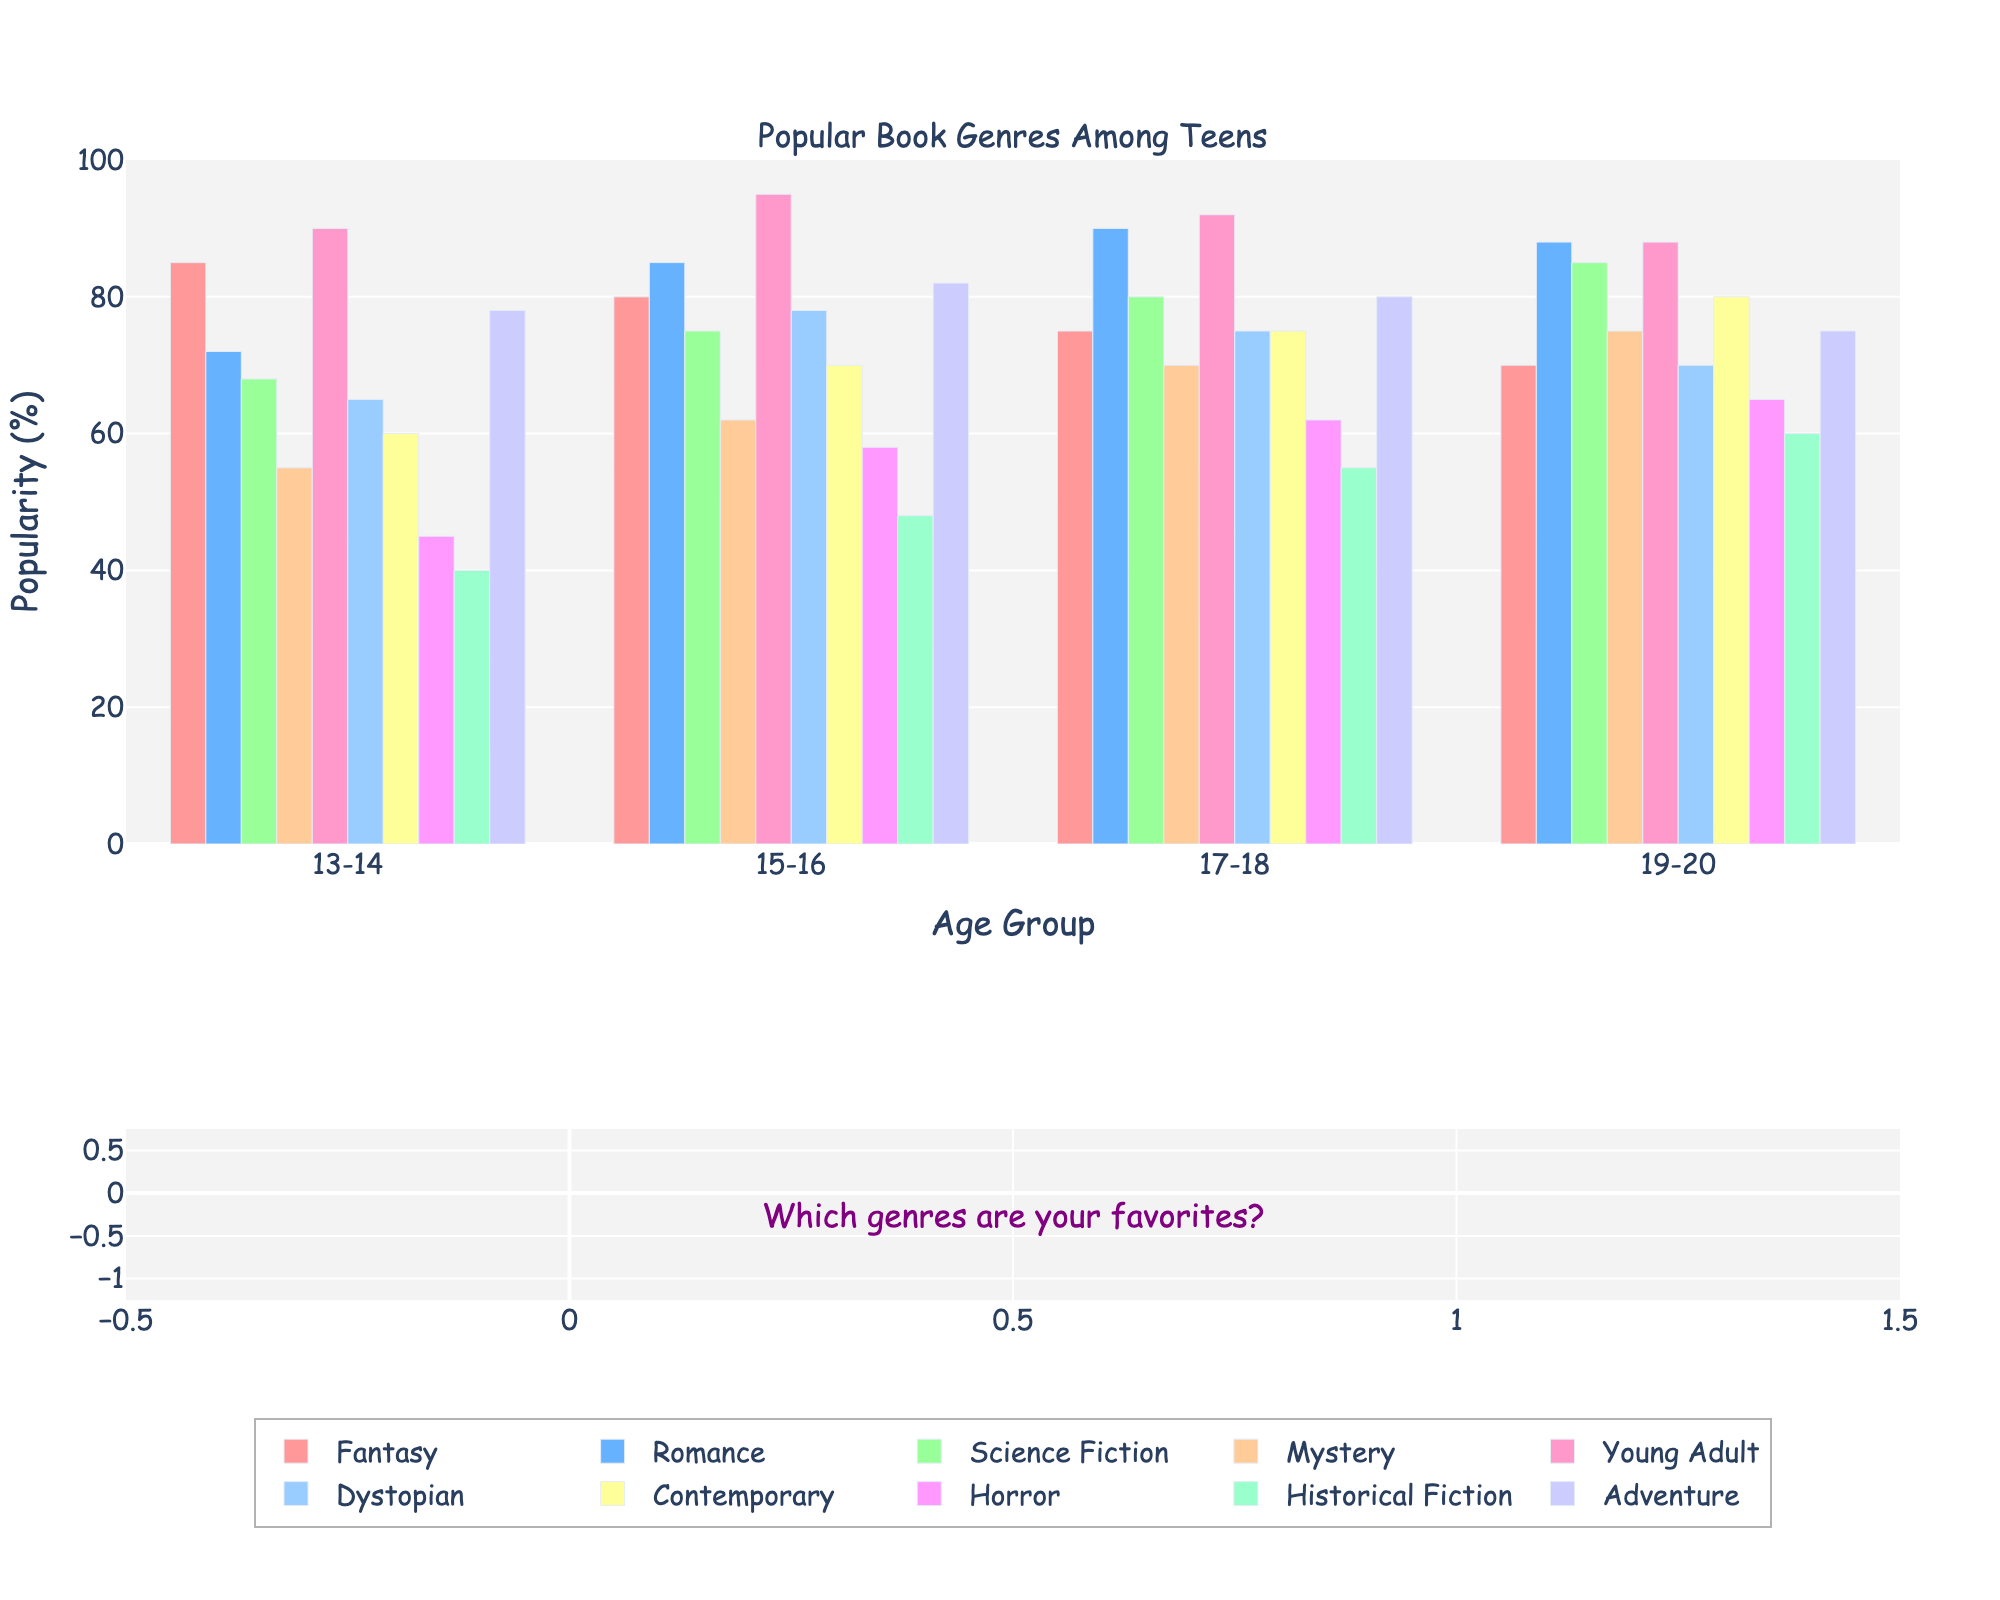What's the most popular genre for the 15-16 age group? Check the height of the bars for the 15-16 age group. The tallest bar corresponds to the Young Adult genre at 95%.
Answer: Young Adult Which age group has the highest preference for Science Fiction? Look at the bar heights for Science Fiction across all age groups. The '19-20' age group has the highest bar at 85%.
Answer: 19-20 How does the popularity of Fantasy change as age increases? Observe the height of the Fantasy bars. It decreases from 85% in '13-14' to 70% in '19-20'.
Answer: Decreases Is Romance more popular among 17-18-year-olds or 13-14-year-olds? Compare the heights of the Romance bars for these age groups. The 17-18 bar is taller at 90% compared to 72% for 13-14-year-olds.
Answer: 17-18-year-olds Which genre has the lowest popularity among 19-20-year-olds? Identify the shortest bar in the 19-20 age group. Horror is the lowest at 65%.
Answer: Horror What's the average popularity of Mystery across all age groups? Sum the values for Mystery (55 + 62 + 70 + 75) and divide by the number of groups (4). (55+62+70+75)/4 = 262/4 = 65.5.
Answer: 65.5 Between Dystopian and Horror, which genre shows more consistent popularity across all age groups? Compare the bar heights' variance for Dystopian and Horror. Dystopian has less variance (65-78) vs. Horror (45-65).
Answer: Dystopian How much more popular is Young Adult compared to Historical Fiction for the 17-18 age group? Subtract the Historical Fiction value (55%) from the Young Adult value (92%). 92% - 55% = 37%.
Answer: 37% Is the popularity of Contemporary greater for the 19-20 age group compared to the 13-14 age group? Compare the bar heights for Contemporary for these age groups. The 19-20 bar is taller at 80% compared to 60% for 13-14-year-olds.
Answer: Yes What's the difference in Adventure popularity between the 13-14 and 15-16 age groups? Subtract the 13-14 value (78%) from the 15-16 value (82%). 82% - 78% = 4%.
Answer: 4% 